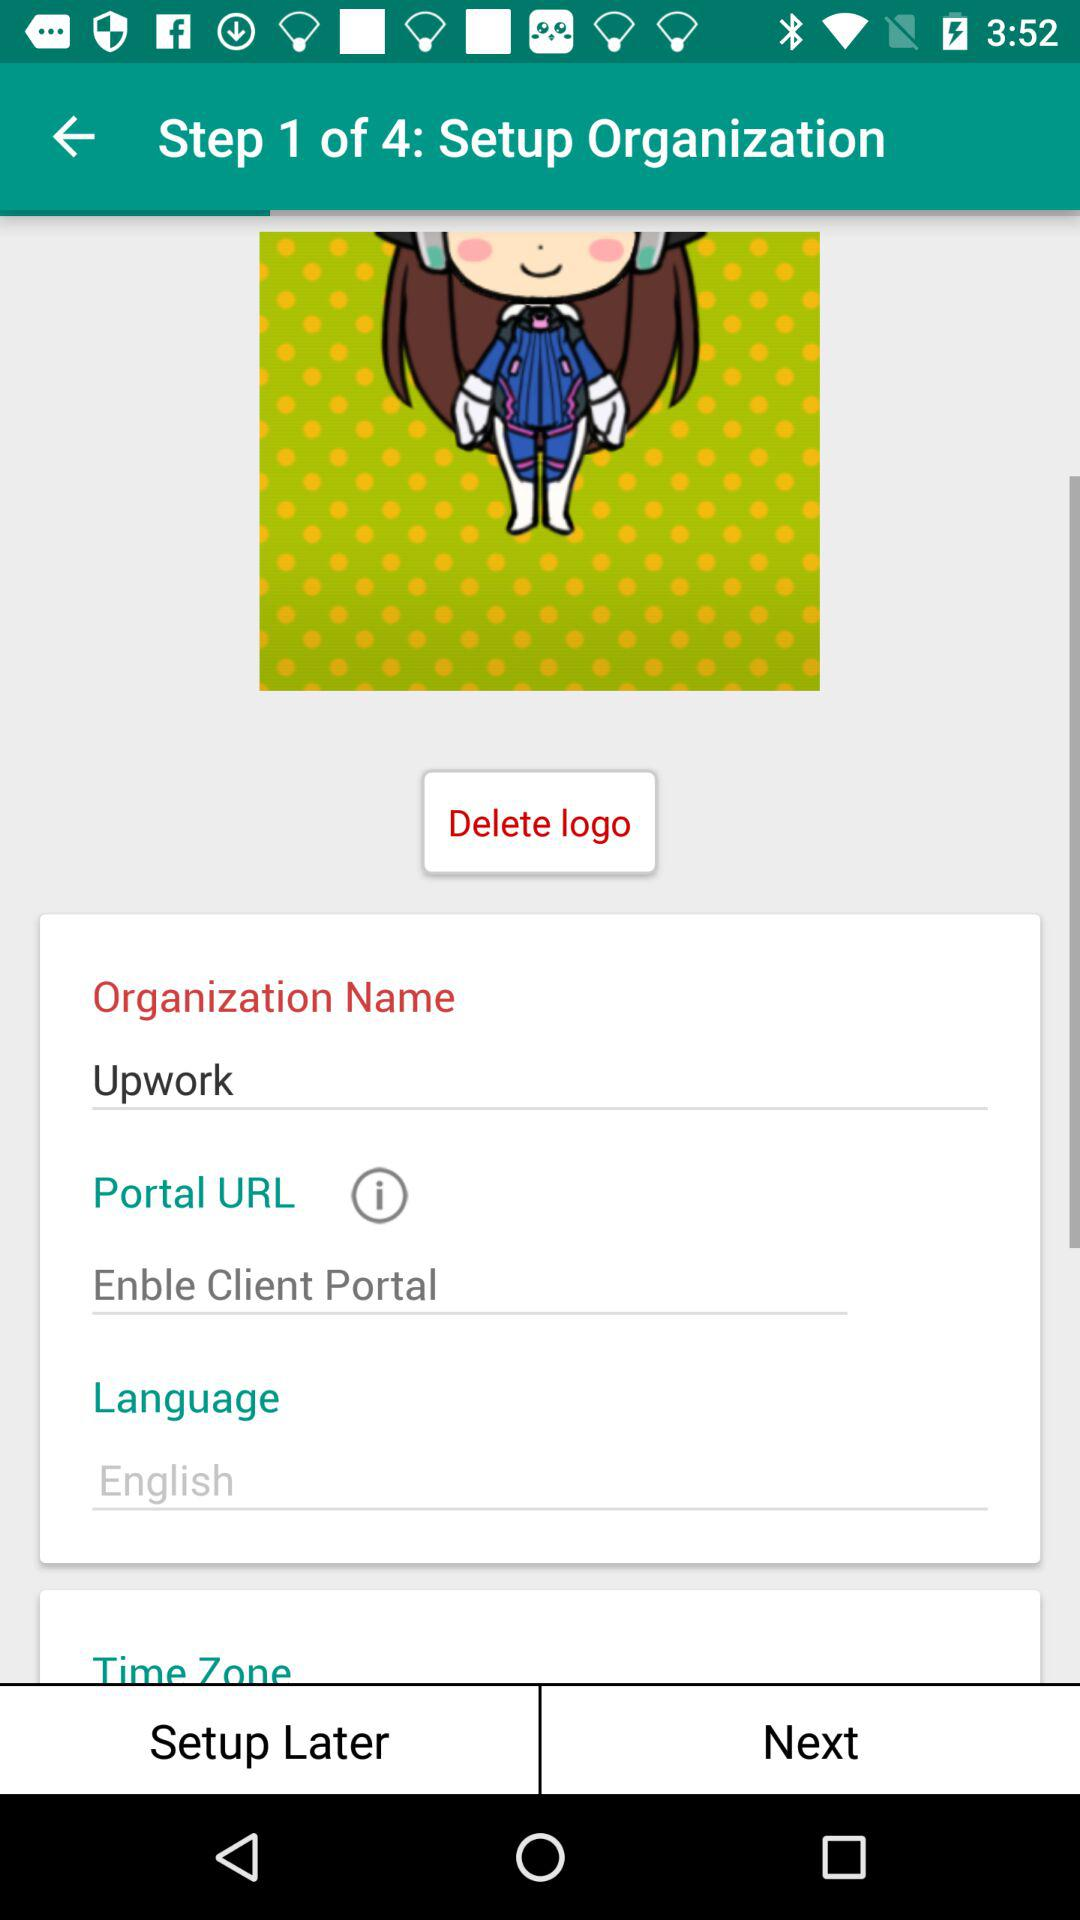What is the organization name? The organization name is "Upwork". 